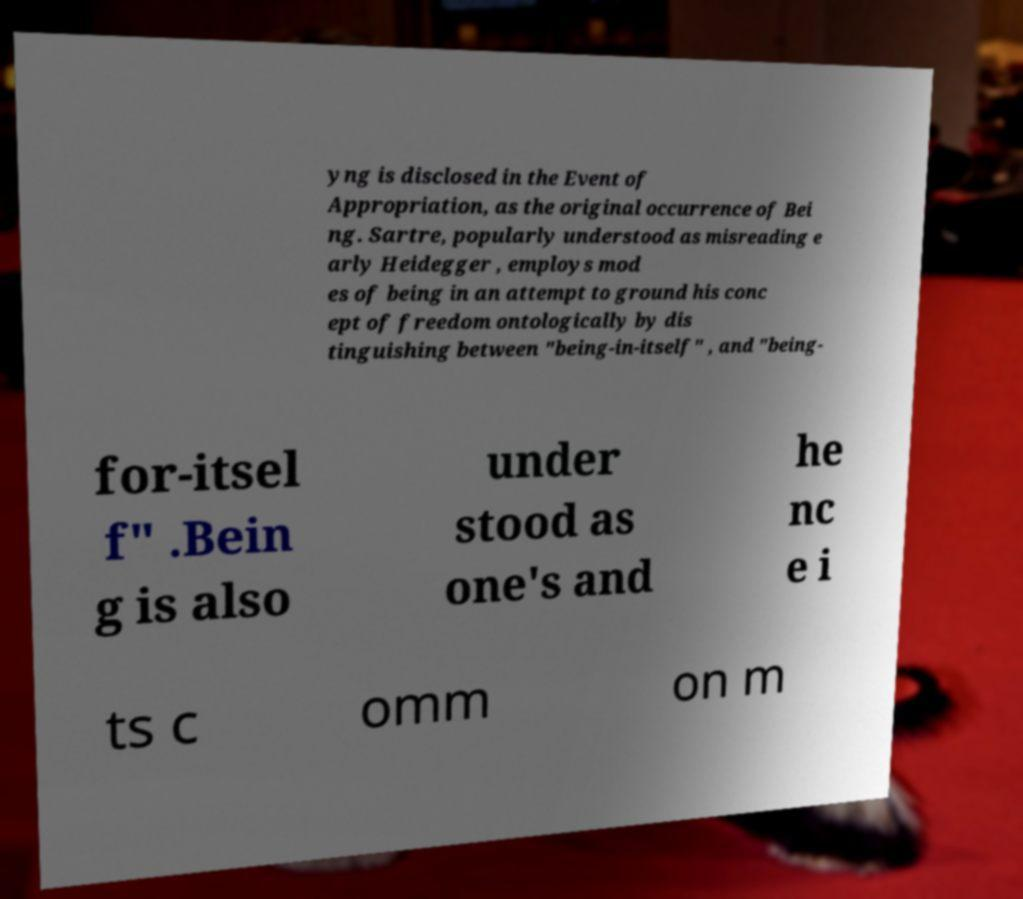For documentation purposes, I need the text within this image transcribed. Could you provide that? yng is disclosed in the Event of Appropriation, as the original occurrence of Bei ng. Sartre, popularly understood as misreading e arly Heidegger , employs mod es of being in an attempt to ground his conc ept of freedom ontologically by dis tinguishing between "being-in-itself" , and "being- for-itsel f" .Bein g is also under stood as one's and he nc e i ts c omm on m 